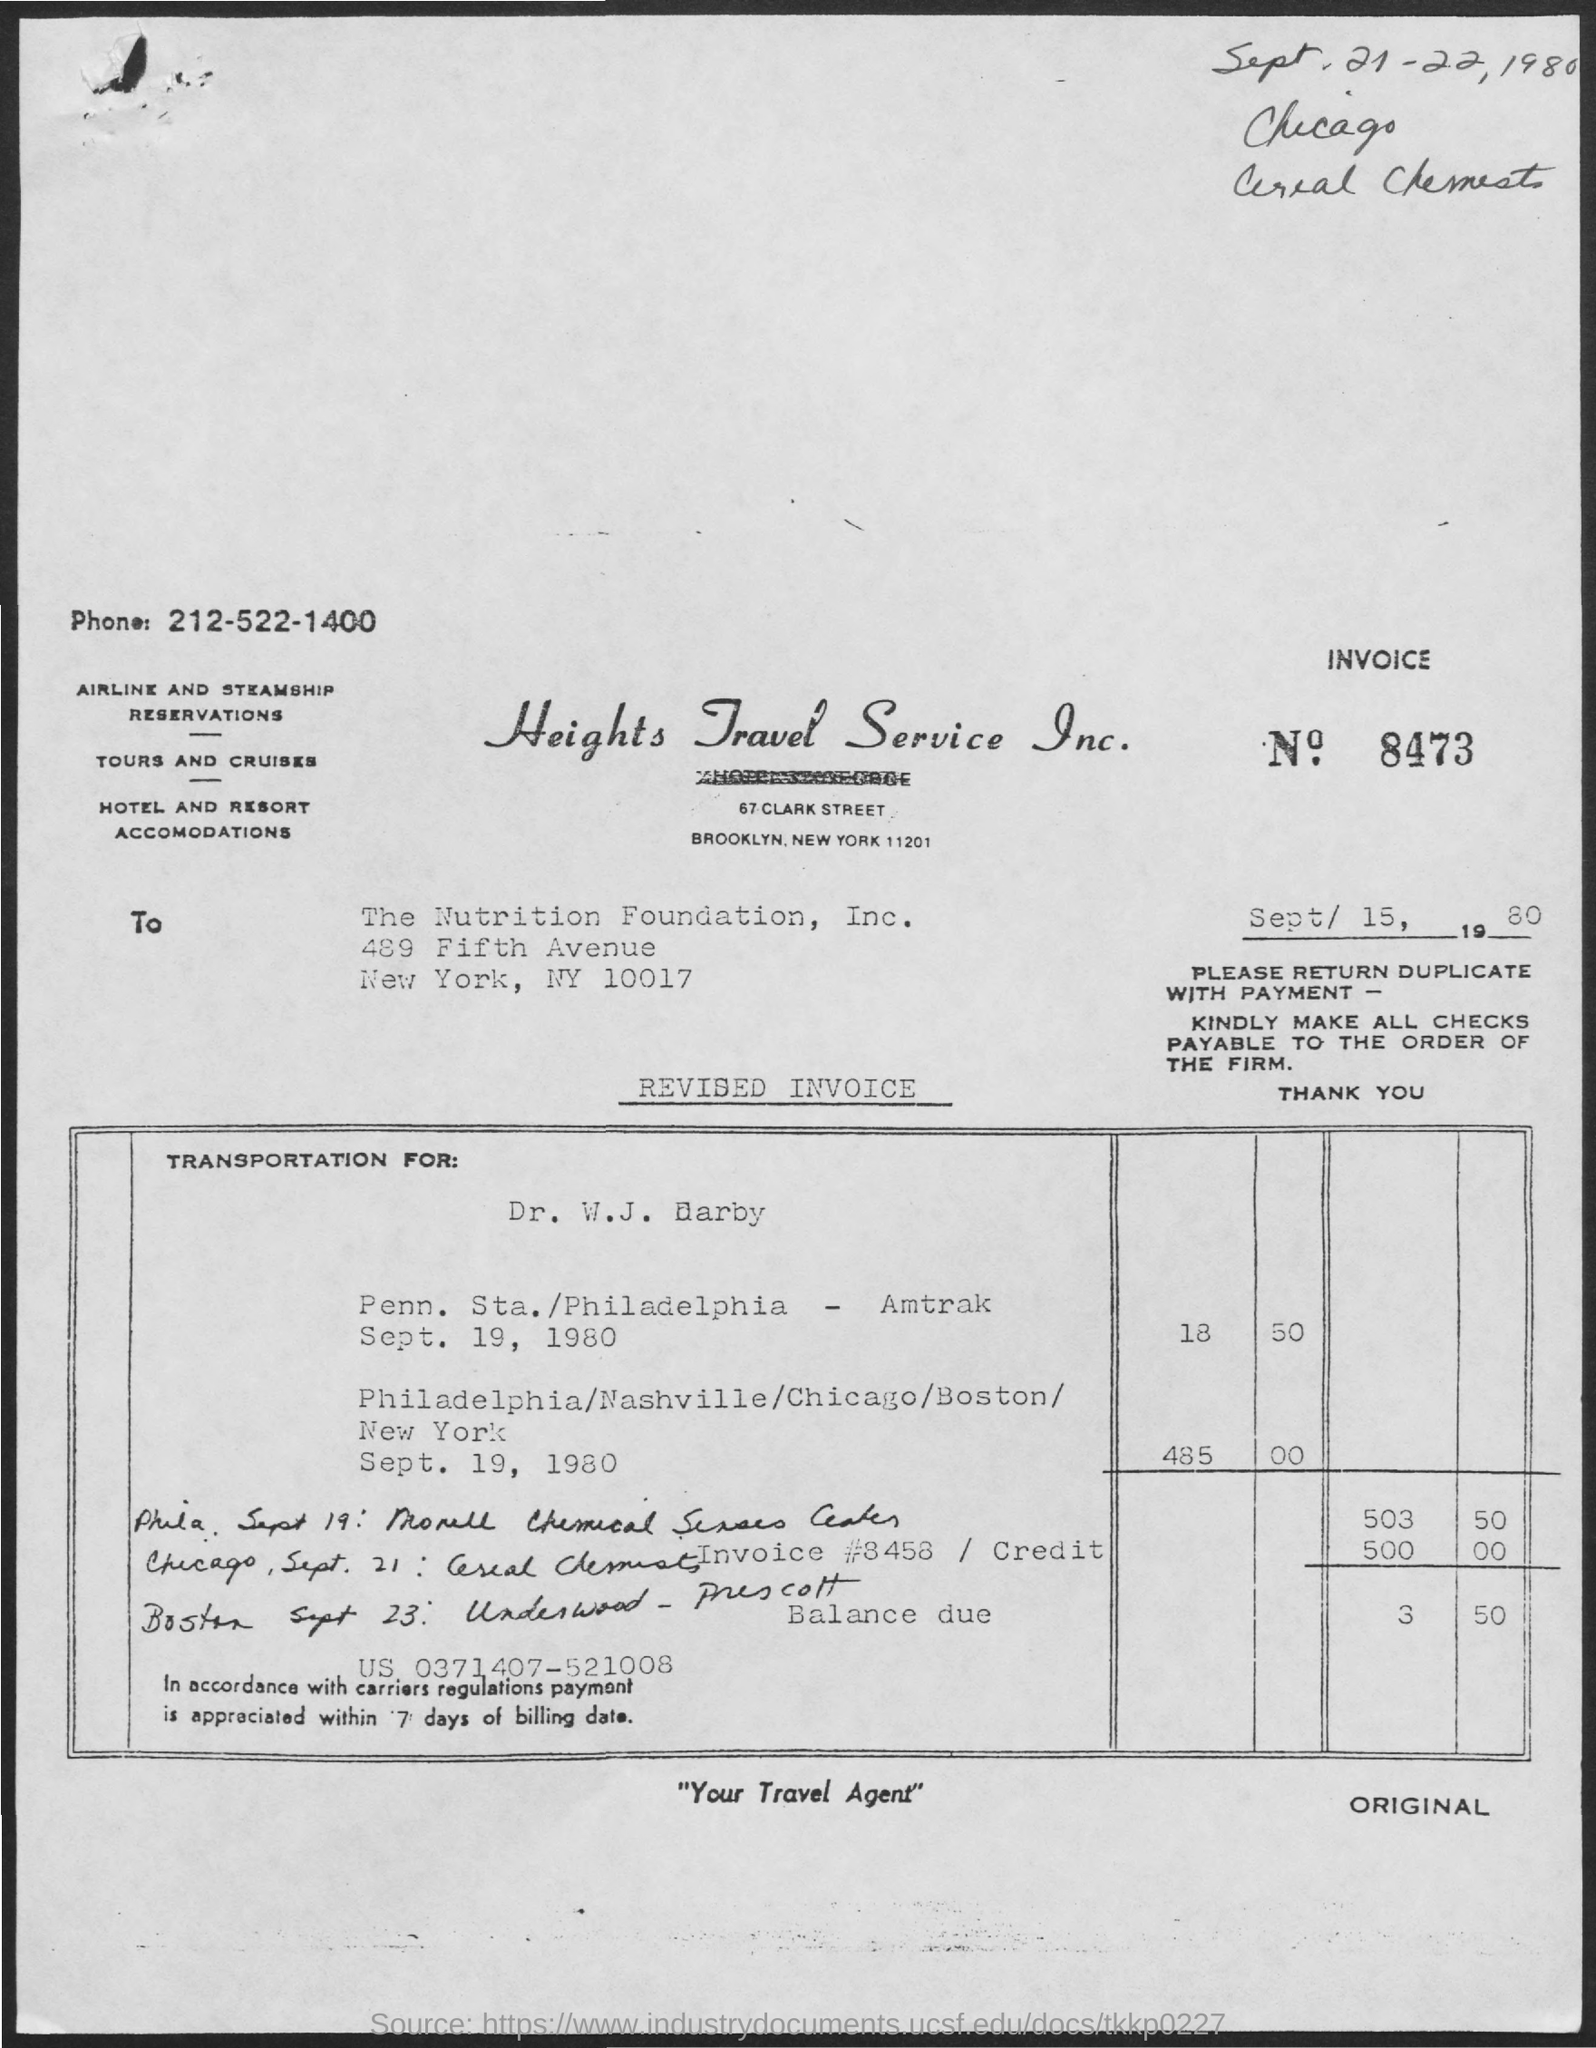Give some essential details in this illustration. The invoice number is 8473. The invoice number and date are provided below. The date is September 15, 1980. The handwritten date at the top right of the document is "September 21-22, 1980. 